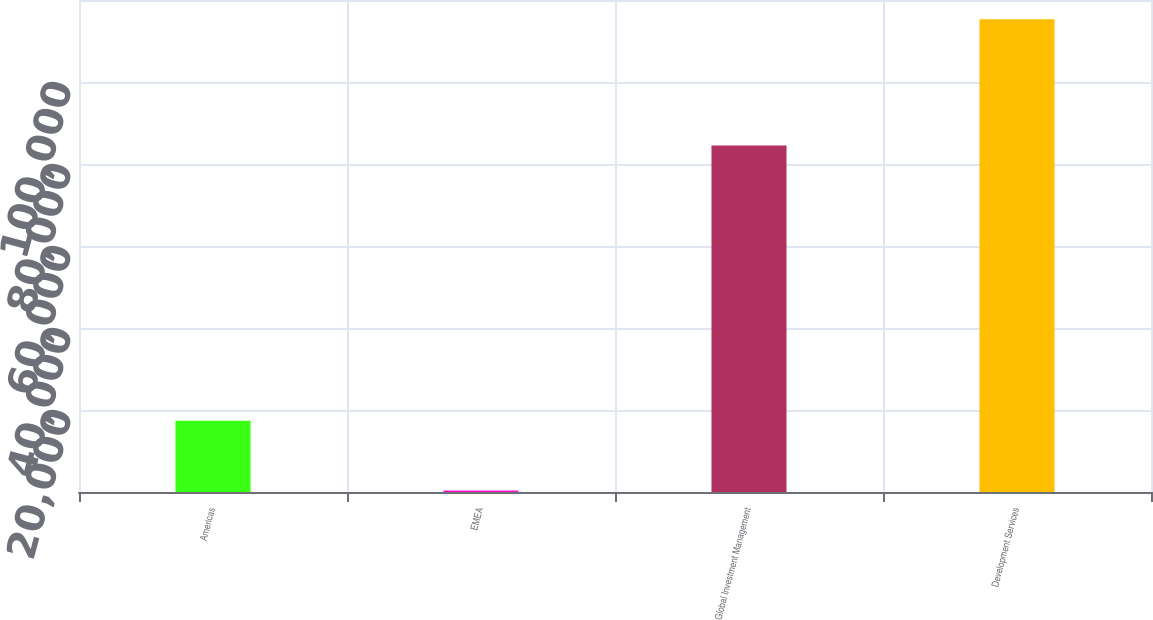Convert chart. <chart><loc_0><loc_0><loc_500><loc_500><bar_chart><fcel>Americas<fcel>EMEA<fcel>Global Investment Management<fcel>Development Services<nl><fcel>17380<fcel>392<fcel>84534<fcel>115326<nl></chart> 